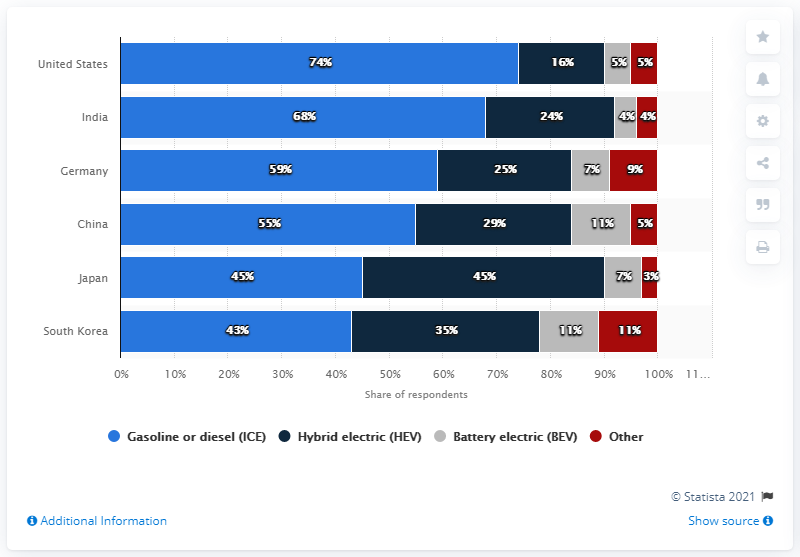Give some essential details in this illustration. The navy blue color on the vehicle indicates that it is a hybrid electric vehicle (HEV). In Germany, the difference in percentage between gasoline and hybrid electric vehicles is 34%. 